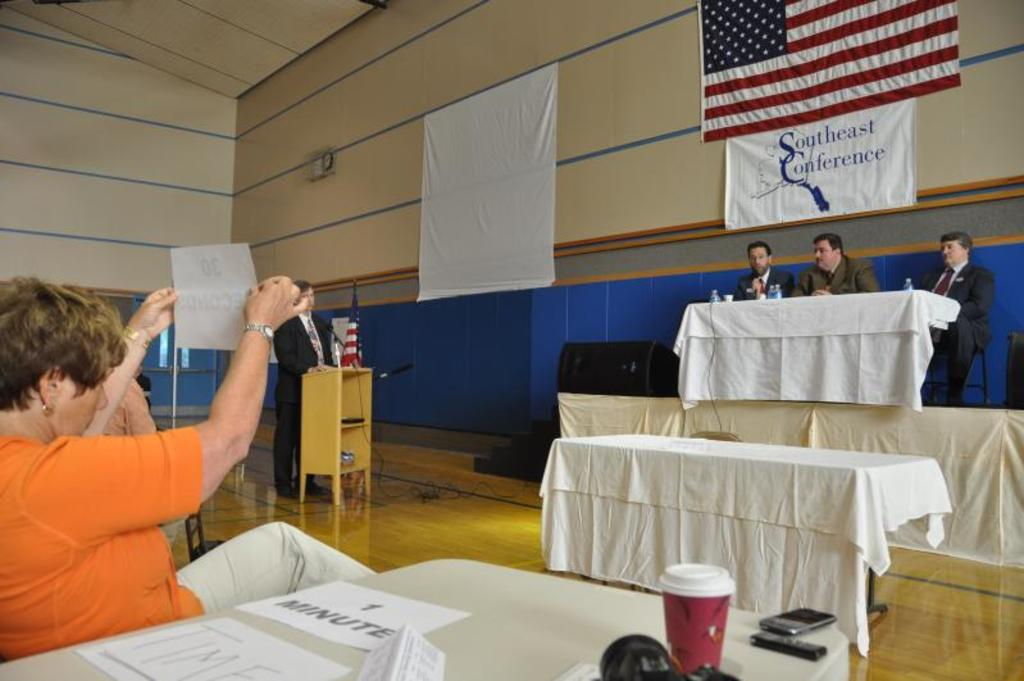Who is the main subject in the image? There is a woman in the image. What is the woman doing in the image? The woman is sitting. Are there any other people in the image besides the woman? Yes, there are people in the image. What are the people doing in the image? The people are sitting on chairs. What type of circle can be seen in the image? There is no circle present in the image. Is it raining in the image? There is no indication of rain in the image. 